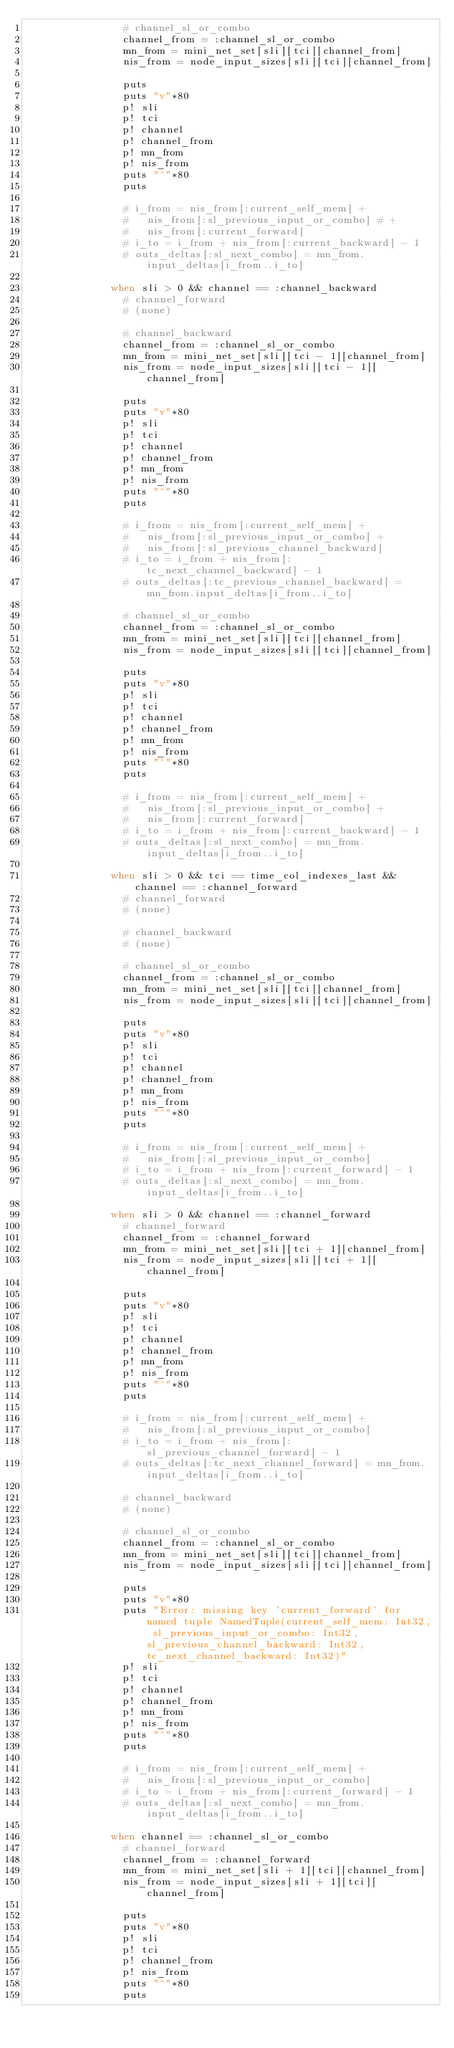<code> <loc_0><loc_0><loc_500><loc_500><_Crystal_>                # channel_sl_or_combo
                channel_from = :channel_sl_or_combo
                mn_from = mini_net_set[sli][tci][channel_from]
                nis_from = node_input_sizes[sli][tci][channel_from]

                puts
                puts "v"*80
                p! sli
                p! tci
                p! channel
                p! channel_from
                p! mn_from
                p! nis_from
                puts "^"*80
                puts

                # i_from = nis_from[:current_self_mem] +
                #   nis_from[:sl_previous_input_or_combo] # +
                #   nis_from[:current_forward]
                # i_to = i_from + nis_from[:current_backward] - 1
                # outs_deltas[:sl_next_combo] = mn_from.input_deltas[i_from..i_to]

              when sli > 0 && channel == :channel_backward
                # channel_forward
                # (none)

                # channel_backward
                channel_from = :channel_sl_or_combo
                mn_from = mini_net_set[sli][tci - 1][channel_from]
                nis_from = node_input_sizes[sli][tci - 1][channel_from]

                puts
                puts "v"*80
                p! sli
                p! tci
                p! channel
                p! channel_from
                p! mn_from
                p! nis_from
                puts "^"*80
                puts

                # i_from = nis_from[:current_self_mem] +
                #   nis_from[:sl_previous_input_or_combo] +
                #   nis_from[:sl_previous_channel_backward]
                # i_to = i_from + nis_from[:tc_next_channel_backward] - 1
                # outs_deltas[:tc_previous_channel_backward] = mn_from.input_deltas[i_from..i_to]

                # channel_sl_or_combo
                channel_from = :channel_sl_or_combo
                mn_from = mini_net_set[sli][tci][channel_from]
                nis_from = node_input_sizes[sli][tci][channel_from]

                puts
                puts "v"*80
                p! sli
                p! tci
                p! channel
                p! channel_from
                p! mn_from
                p! nis_from
                puts "^"*80
                puts

                # i_from = nis_from[:current_self_mem] +
                #   nis_from[:sl_previous_input_or_combo] +
                #   nis_from[:current_forward]
                # i_to = i_from + nis_from[:current_backward] - 1
                # outs_deltas[:sl_next_combo] = mn_from.input_deltas[i_from..i_to]

              when sli > 0 && tci == time_col_indexes_last && channel == :channel_forward
                # channel_forward
                # (none)

                # channel_backward
                # (none)

                # channel_sl_or_combo
                channel_from = :channel_sl_or_combo
                mn_from = mini_net_set[sli][tci][channel_from]
                nis_from = node_input_sizes[sli][tci][channel_from]

                puts
                puts "v"*80
                p! sli
                p! tci
                p! channel
                p! channel_from
                p! mn_from
                p! nis_from
                puts "^"*80
                puts

                # i_from = nis_from[:current_self_mem] +
                #   nis_from[:sl_previous_input_or_combo]
                # i_to = i_from + nis_from[:current_forward] - 1
                # outs_deltas[:sl_next_combo] = mn_from.input_deltas[i_from..i_to]

              when sli > 0 && channel == :channel_forward
                # channel_forward
                channel_from = :channel_forward
                mn_from = mini_net_set[sli][tci + 1][channel_from]
                nis_from = node_input_sizes[sli][tci + 1][channel_from]

                puts
                puts "v"*80
                p! sli
                p! tci
                p! channel
                p! channel_from
                p! mn_from
                p! nis_from
                puts "^"*80
                puts

                # i_from = nis_from[:current_self_mem] +
                #   nis_from[:sl_previous_input_or_combo]
                # i_to = i_from + nis_from[:sl_previous_channel_forward] - 1
                # outs_deltas[:tc_next_channel_forward] = mn_from.input_deltas[i_from..i_to]

                # channel_backward
                # (none)

                # channel_sl_or_combo
                channel_from = :channel_sl_or_combo
                mn_from = mini_net_set[sli][tci][channel_from]
                nis_from = node_input_sizes[sli][tci][channel_from]

                puts
                puts "v"*80
                puts "Error: missing key 'current_forward' for named tuple NamedTuple(current_self_mem: Int32, sl_previous_input_or_combo: Int32, sl_previous_channel_backward: Int32, tc_next_channel_backward: Int32)"
                p! sli
                p! tci
                p! channel
                p! channel_from
                p! mn_from
                p! nis_from
                puts "^"*80
                puts

                # i_from = nis_from[:current_self_mem] +
                #   nis_from[:sl_previous_input_or_combo]
                # i_to = i_from + nis_from[:current_forward] - 1
                # outs_deltas[:sl_next_combo] = mn_from.input_deltas[i_from..i_to]

              when channel == :channel_sl_or_combo
                # channel_forward
                channel_from = :channel_forward
                mn_from = mini_net_set[sli + 1][tci][channel_from]
                nis_from = node_input_sizes[sli + 1][tci][channel_from]

                puts
                puts "v"*80
                p! sli
                p! tci
                p! channel_from
                p! nis_from
                puts "^"*80
                puts
</code> 